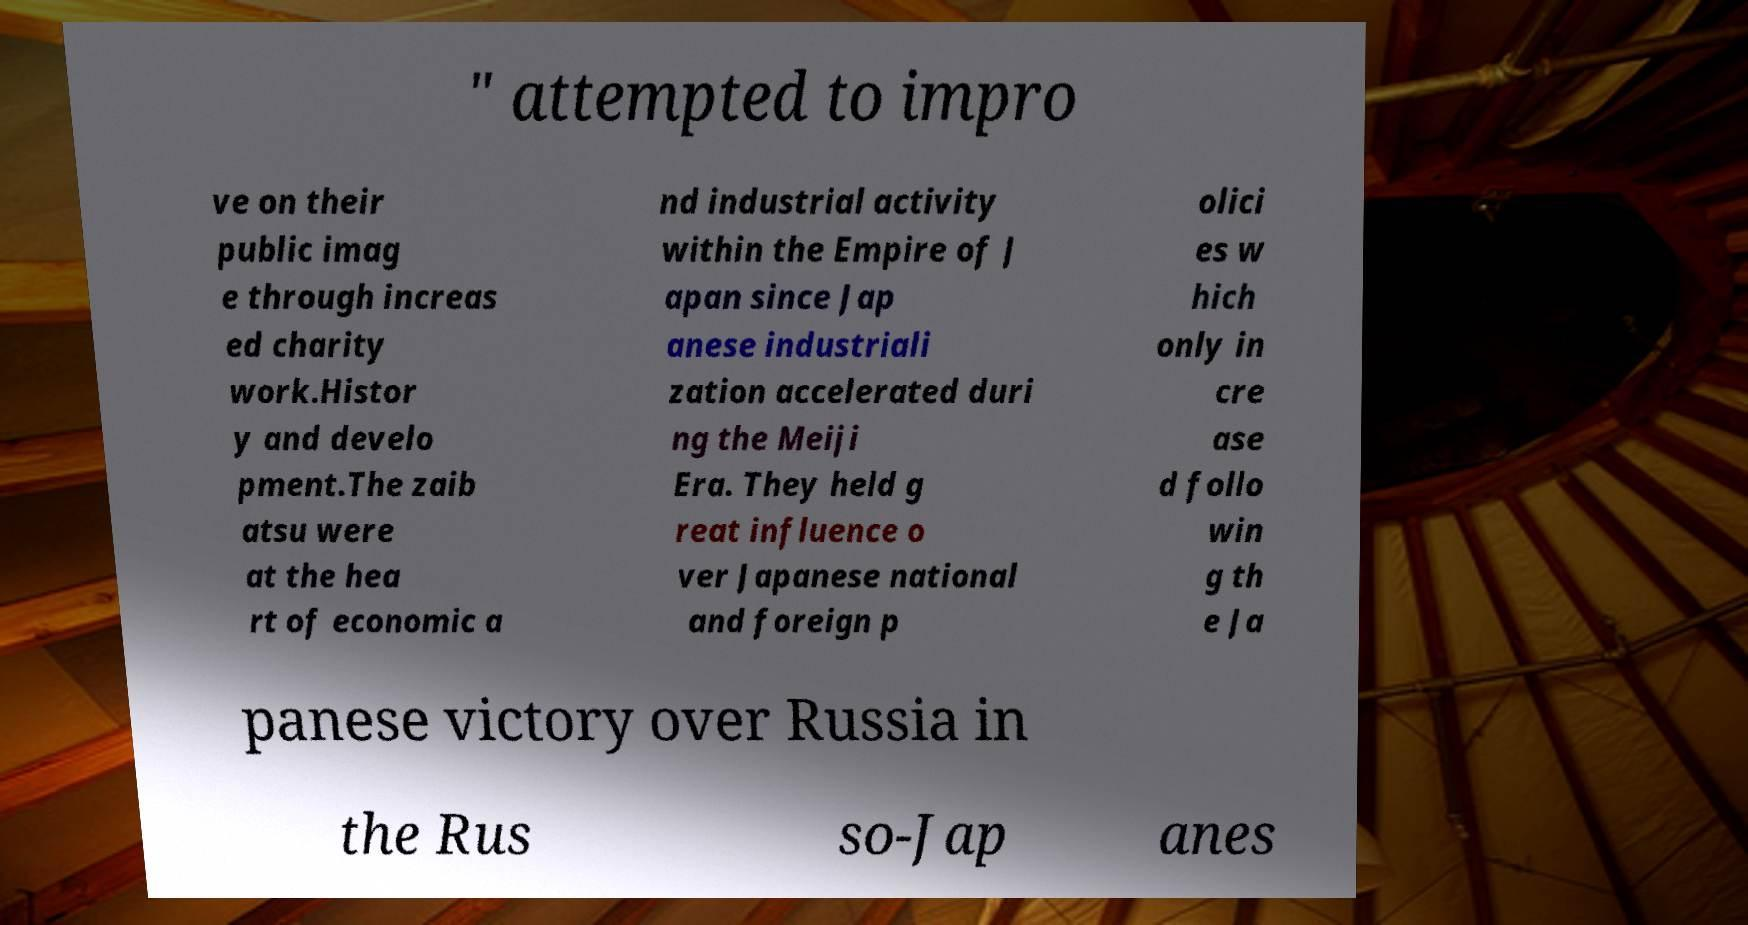Could you extract and type out the text from this image? " attempted to impro ve on their public imag e through increas ed charity work.Histor y and develo pment.The zaib atsu were at the hea rt of economic a nd industrial activity within the Empire of J apan since Jap anese industriali zation accelerated duri ng the Meiji Era. They held g reat influence o ver Japanese national and foreign p olici es w hich only in cre ase d follo win g th e Ja panese victory over Russia in the Rus so-Jap anes 